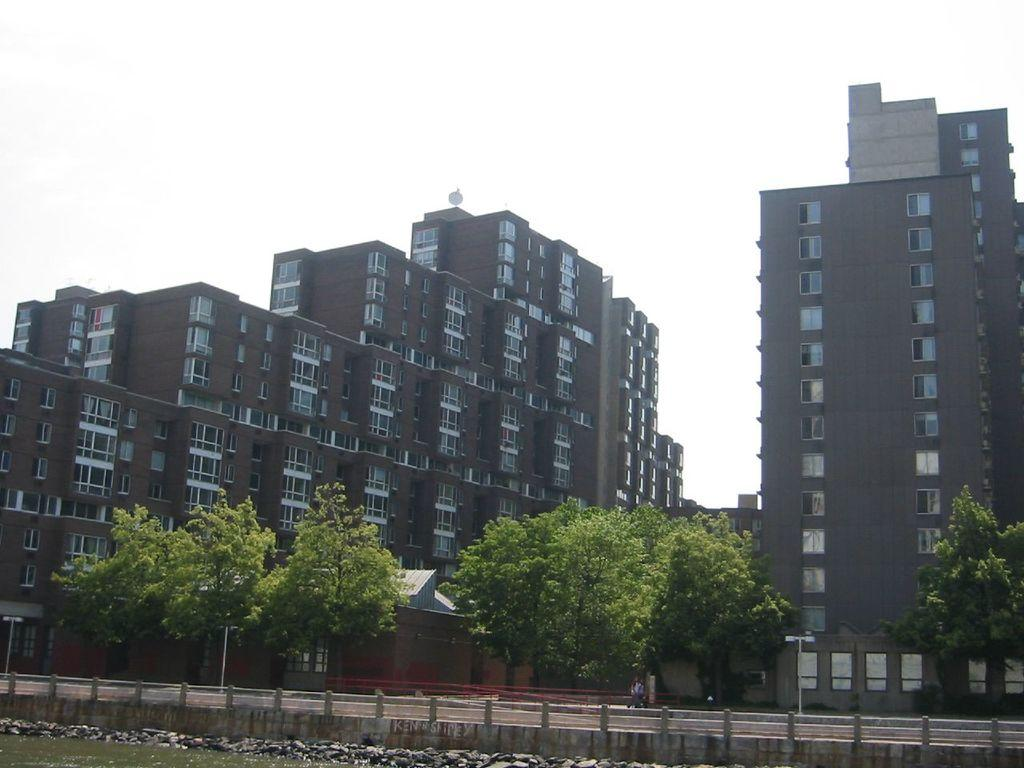What type of structures can be seen in the image? There are buildings in the image. What is located in front of the buildings? There are trees in front of the buildings. What else can be seen in the image besides the buildings and trees? There is a road visible in the image. How many birds are perched on the frame of the image? There are no birds or frames present in the image; it is a photograph or illustration of buildings, trees, and a road. 